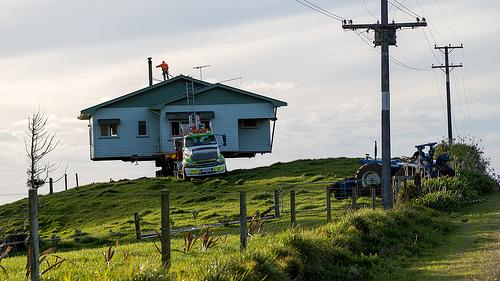What kind of landscape is featured in the image? Rolling green hills with tall grass, fences, and a bare tree. What is happening with the truck's headlights and mirrors? The left headlight is on, and both the left and right-side view mirrors are visible. Mention any other vehicles present in the image apart from the house-carrying truck. A blue and white tractor is present in the field. What type of vehicle is the house on, and what is its color? The house is on a white truck with green lights and stickers. How many telephone poles are in the image, and where are they positioned? There are two telephone poles on grass, and a row of poles in the background. Describe the scene involving the man on the roof. A man wearing orange on the roof stands next to a ladder, possibly working or helping with the transportation of a large house on a truck. List the main objects in the image. Cloudy sky, telephone poles, grassy hill, house on truck, tractor, wooden fence posts, man on roof, and tractor in the field. Provide a concise description of the image's main elements. A man on a roof, a house on a truck, a blue tractor in a grassy field, rolling green hills, telephone poles, cloudy sky, and wooden fence posts. Describe the appearance of the sky in the image. The sky is grayish-blue and cloudy, suggesting a slightly overcast day. What is the predominant color of the tractor? The tractor is predominantly blue and white. 